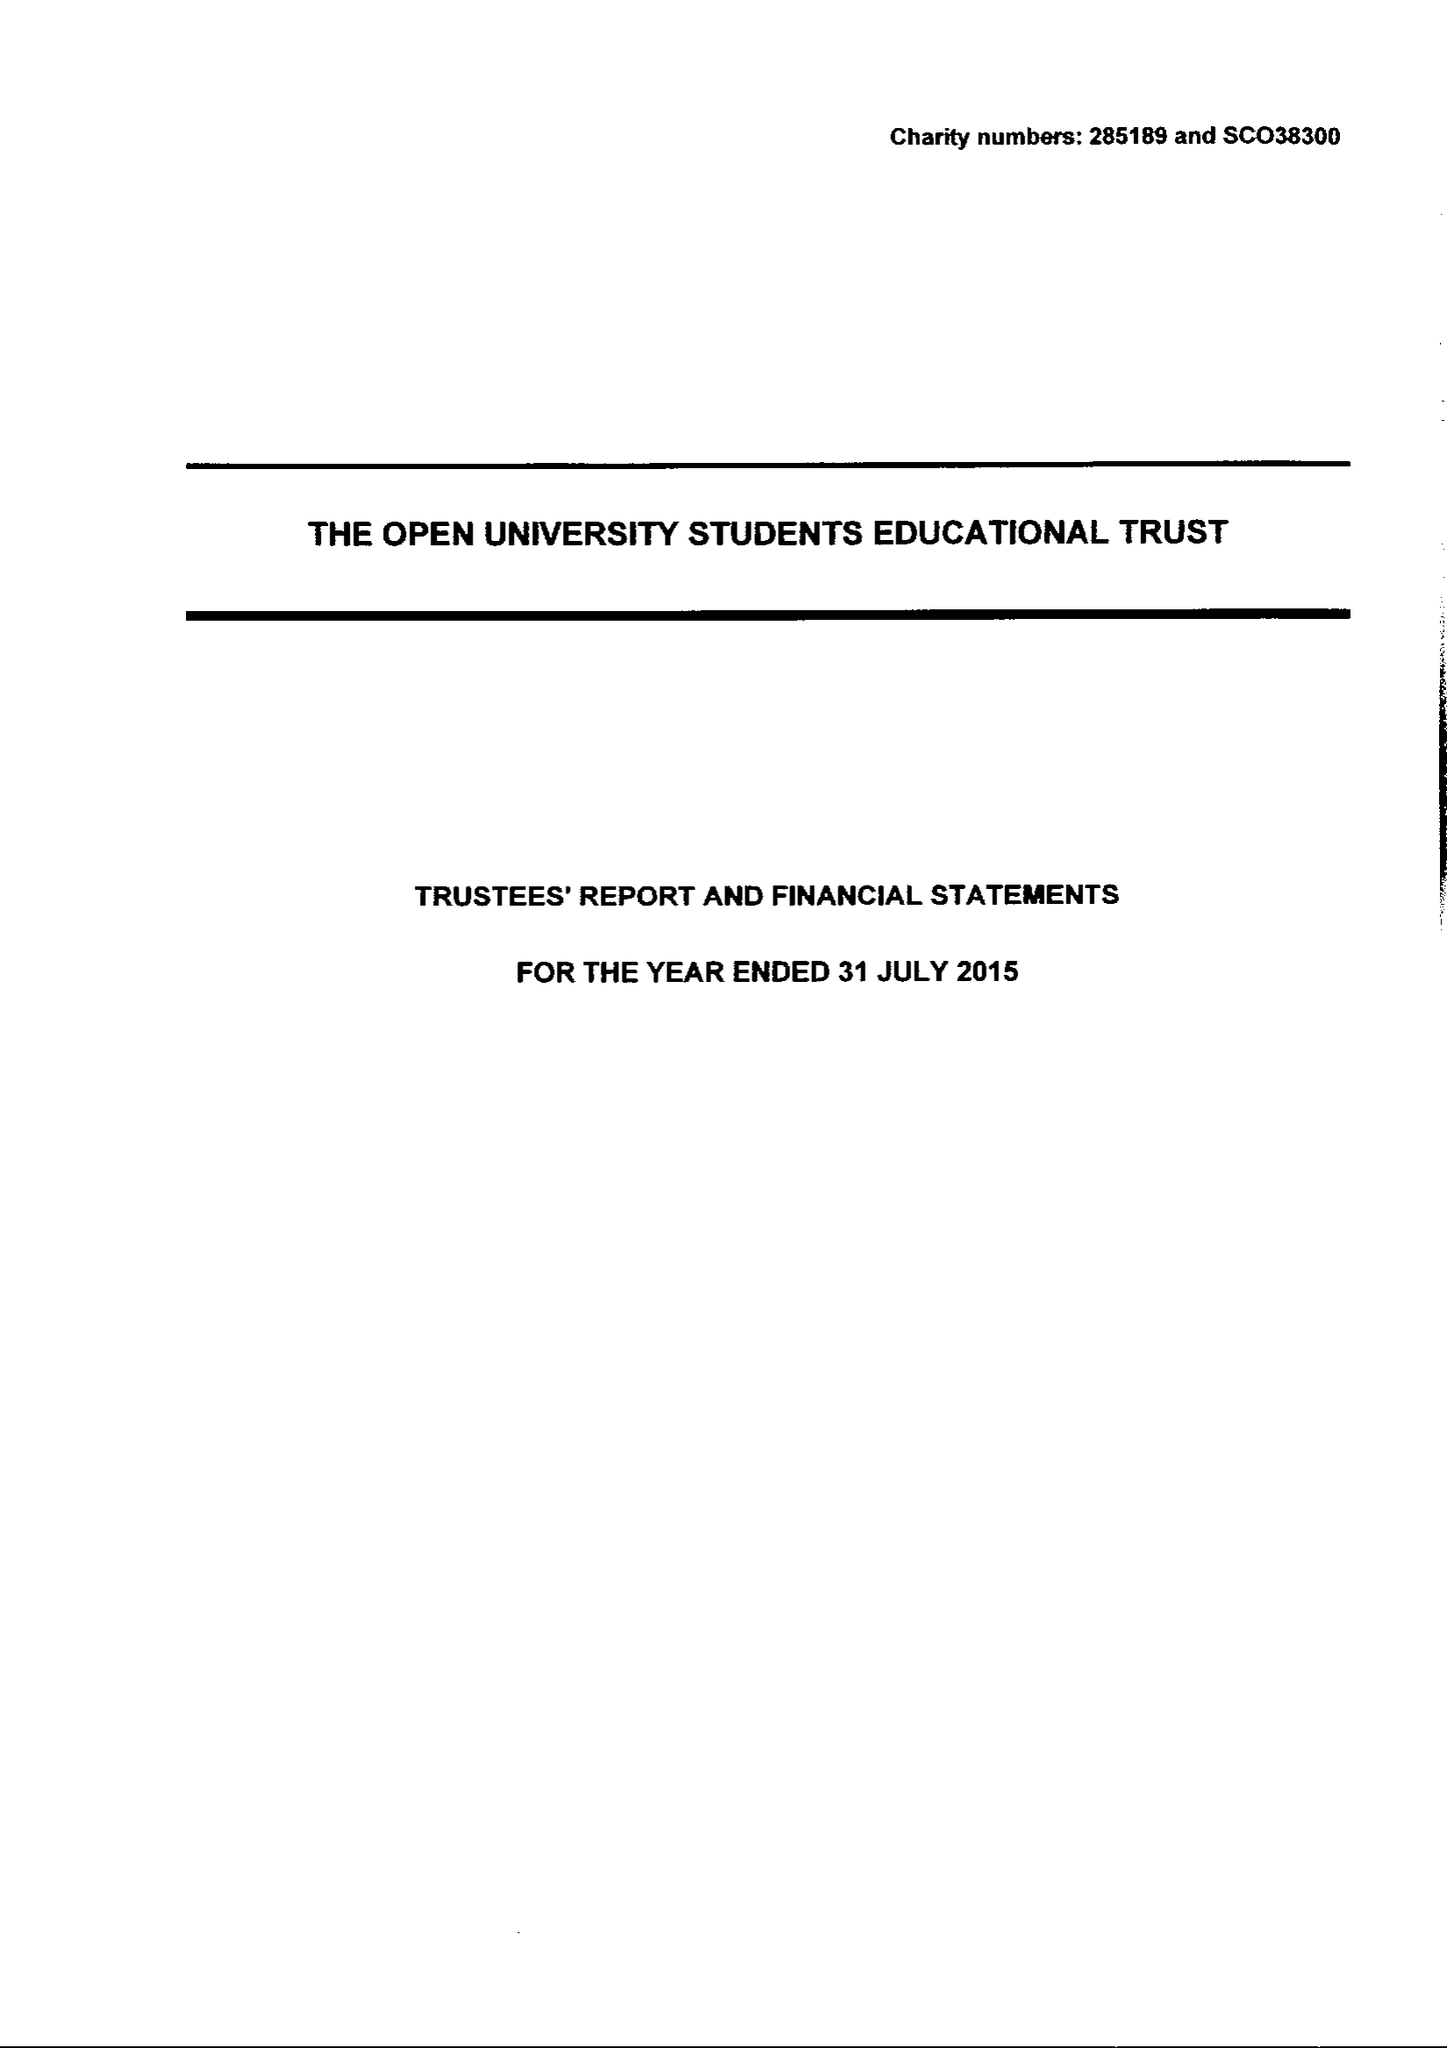What is the value for the spending_annually_in_british_pounds?
Answer the question using a single word or phrase. 125525.00 